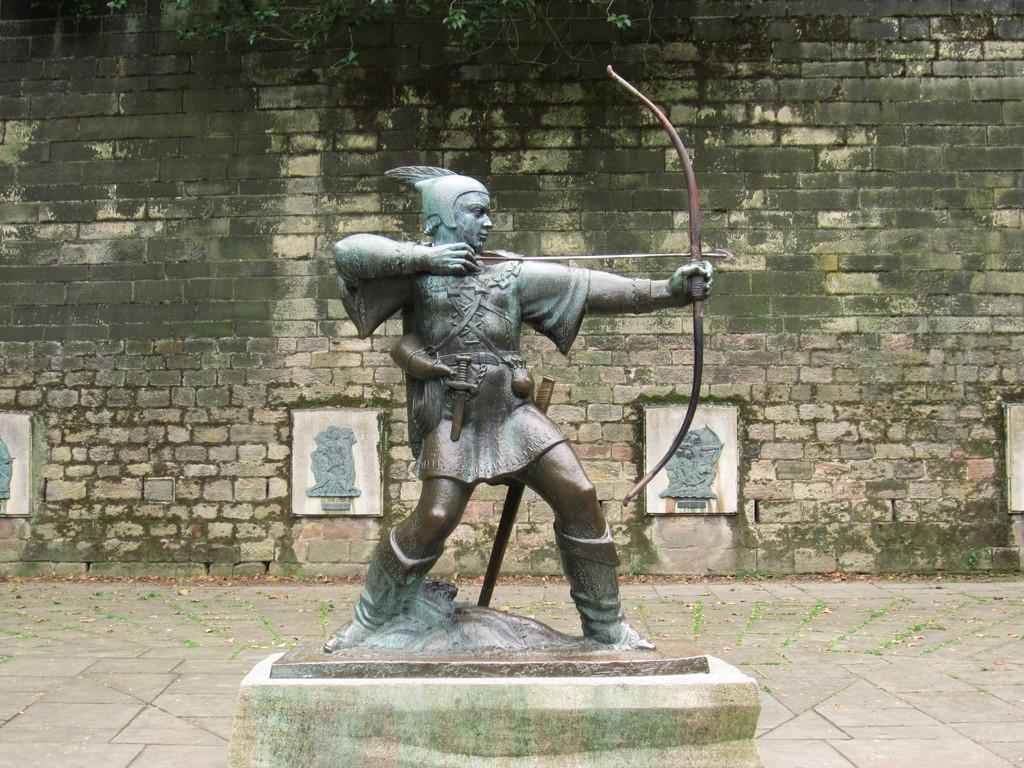Please provide a concise description of this image. In this image, we can see a statue. At the bottom of the image, there is a path. In the background, there are sculptures, wall, leaves and stems. 